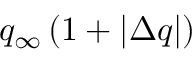<formula> <loc_0><loc_0><loc_500><loc_500>q _ { \infty } \left ( 1 + | \Delta q | \right )</formula> 